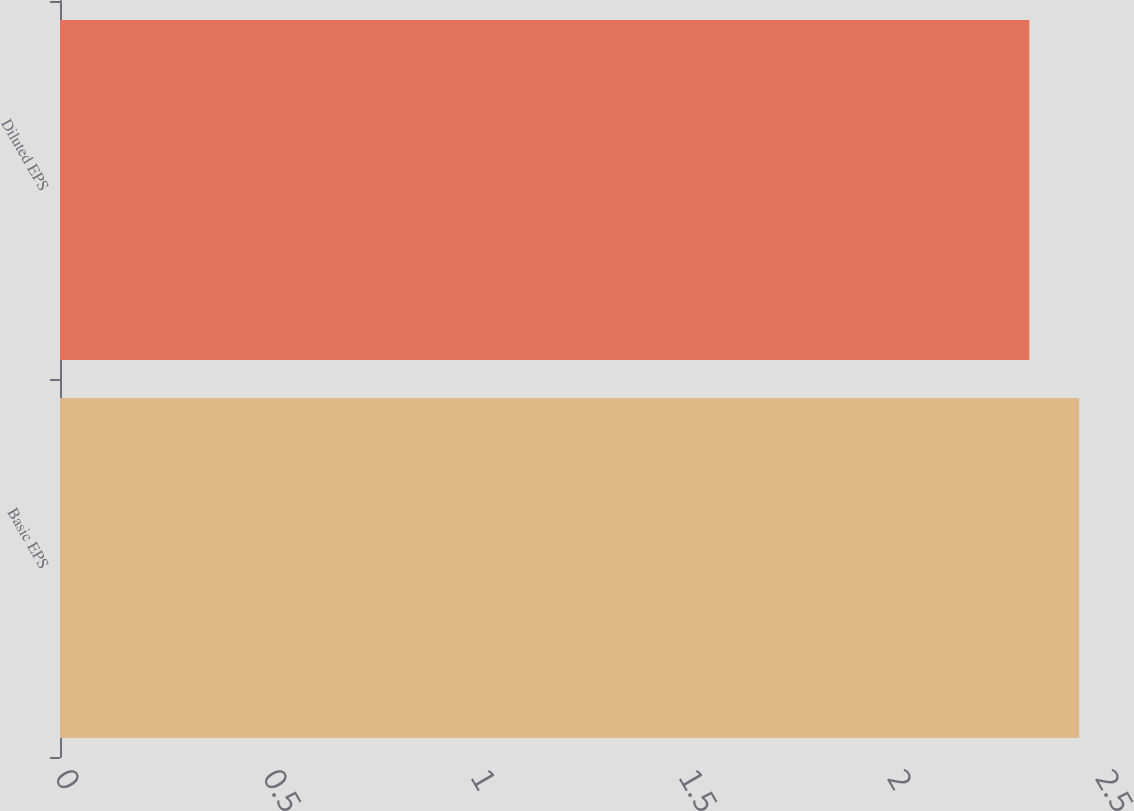Convert chart. <chart><loc_0><loc_0><loc_500><loc_500><bar_chart><fcel>Basic EPS<fcel>Diluted EPS<nl><fcel>2.45<fcel>2.33<nl></chart> 